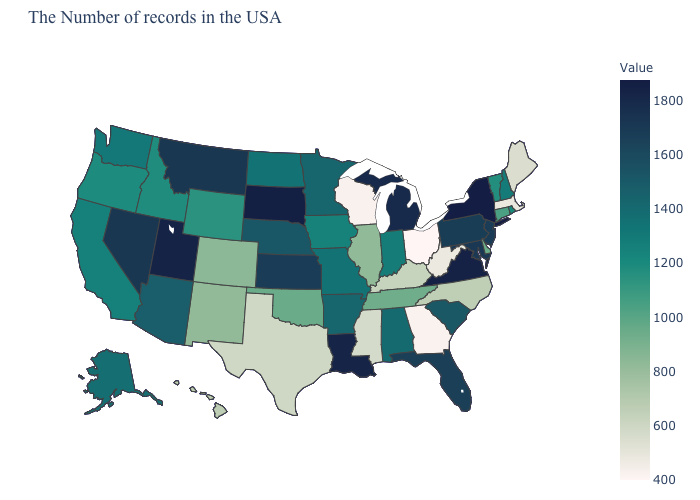Which states have the lowest value in the South?
Give a very brief answer. Georgia. Which states hav the highest value in the MidWest?
Concise answer only. South Dakota. Which states hav the highest value in the West?
Write a very short answer. Utah. 